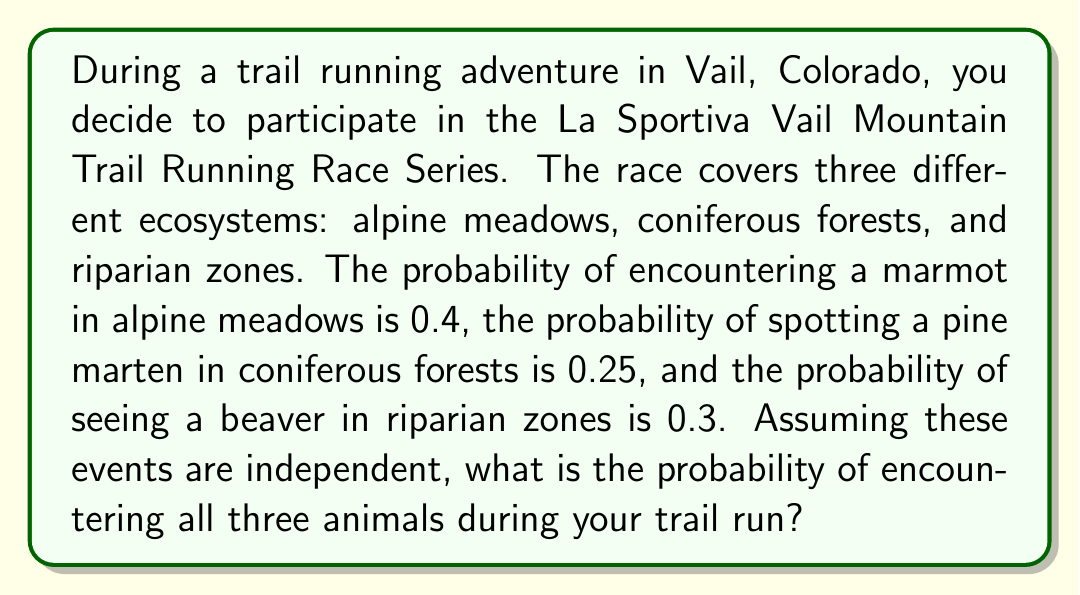Show me your answer to this math problem. To solve this problem, we need to use the multiplication rule for independent events. Since the events are independent (encountering one animal doesn't affect the probability of encountering another), we multiply the individual probabilities together.

Let's define our events:
A: Encountering a marmot in alpine meadows (P(A) = 0.4)
B: Spotting a pine marten in coniferous forests (P(B) = 0.25)
C: Seeing a beaver in riparian zones (P(C) = 0.3)

The probability of all three events occurring is:

$$P(A \text{ and } B \text{ and } C) = P(A) \times P(B) \times P(C)$$

Substituting the given probabilities:

$$P(A \text{ and } B \text{ and } C) = 0.4 \times 0.25 \times 0.3$$

Calculating:

$$P(A \text{ and } B \text{ and } C) = 0.03$$

To express this as a percentage, we multiply by 100:

$$0.03 \times 100 = 3\%$$

Therefore, the probability of encountering all three animals during your trail run is 3% or 0.03.
Answer: 0.03 or 3% 